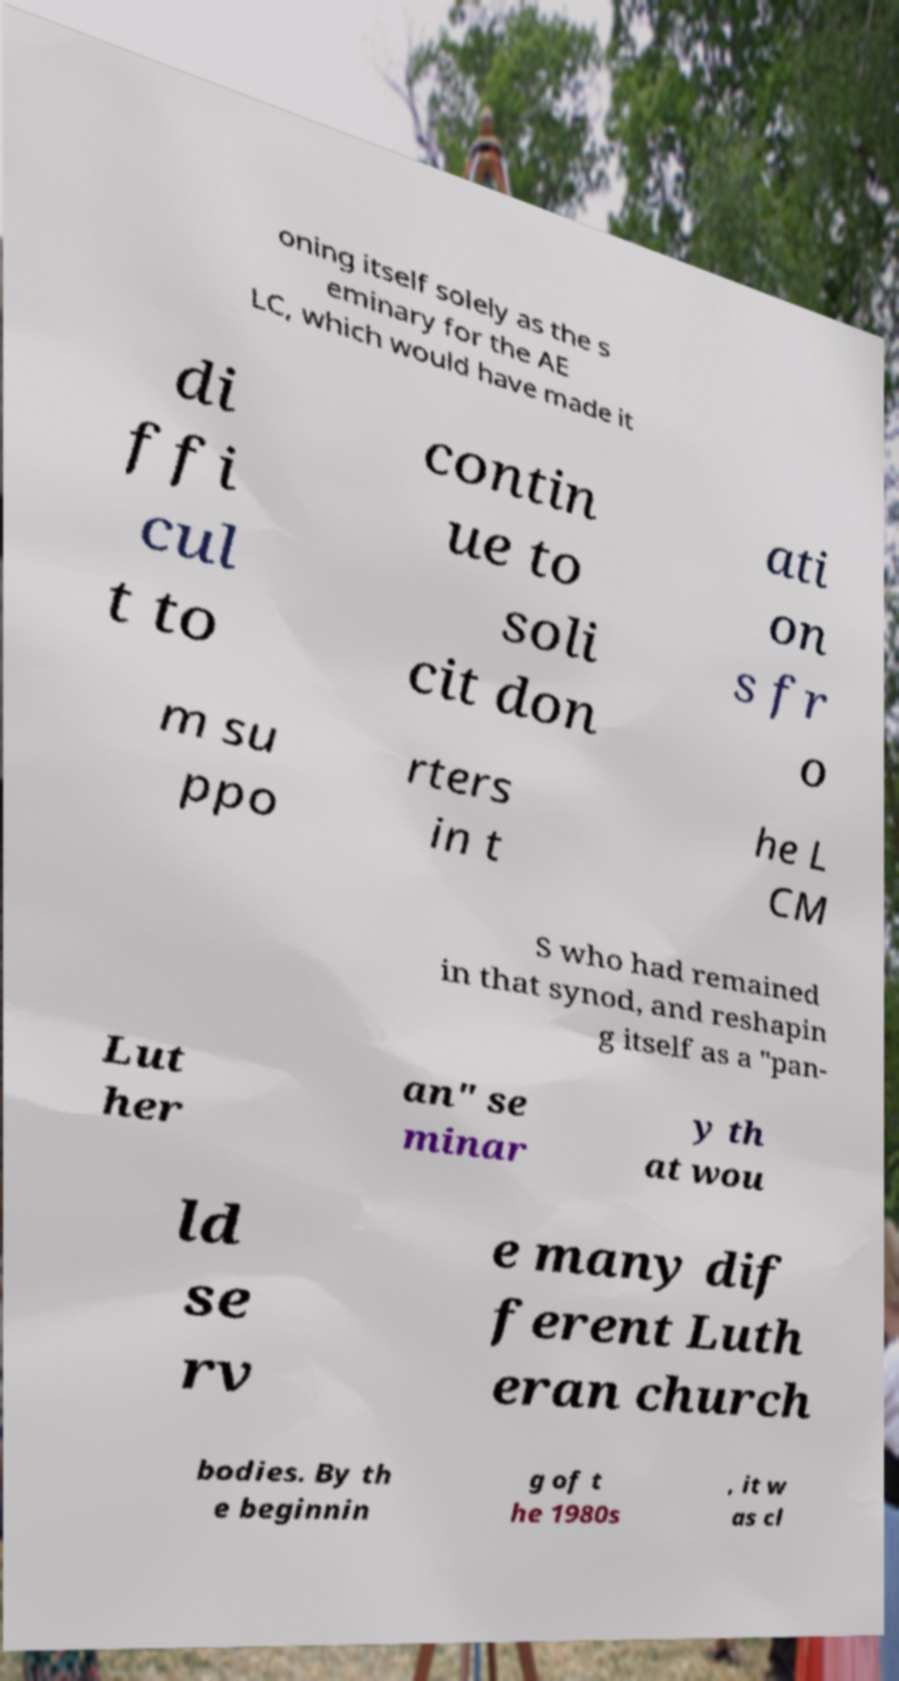For documentation purposes, I need the text within this image transcribed. Could you provide that? oning itself solely as the s eminary for the AE LC, which would have made it di ffi cul t to contin ue to soli cit don ati on s fr o m su ppo rters in t he L CM S who had remained in that synod, and reshapin g itself as a "pan- Lut her an" se minar y th at wou ld se rv e many dif ferent Luth eran church bodies. By th e beginnin g of t he 1980s , it w as cl 